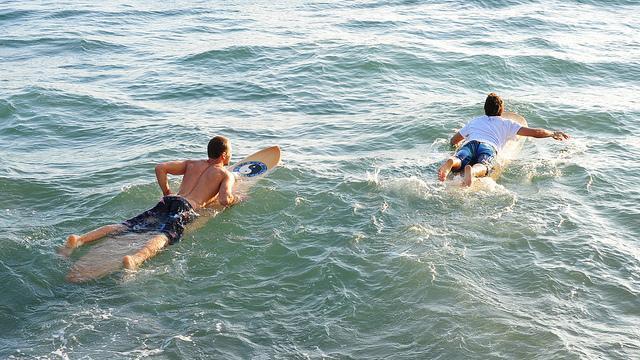How many people are in the water?
Give a very brief answer. 2. How many people are there?
Give a very brief answer. 2. 